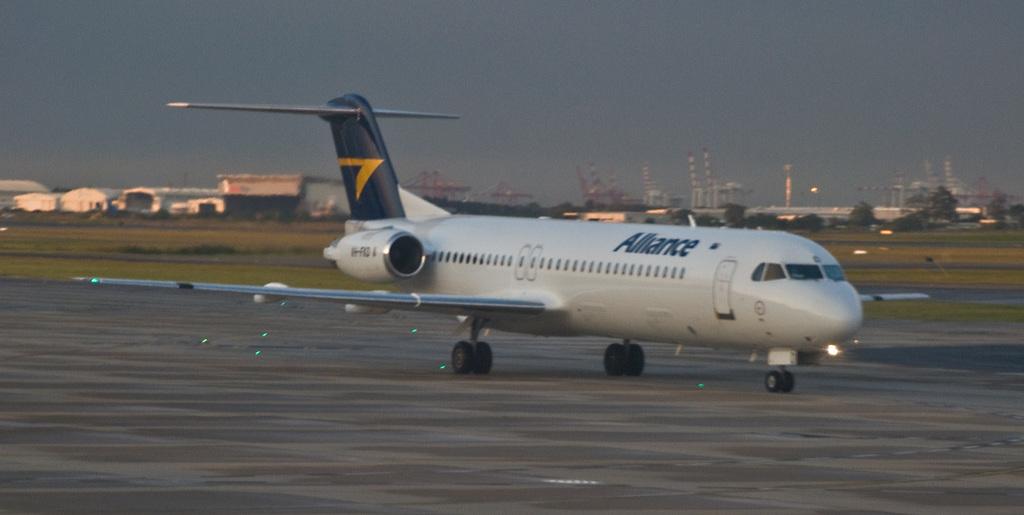What airline is this plane from?
Give a very brief answer. Alliance. 